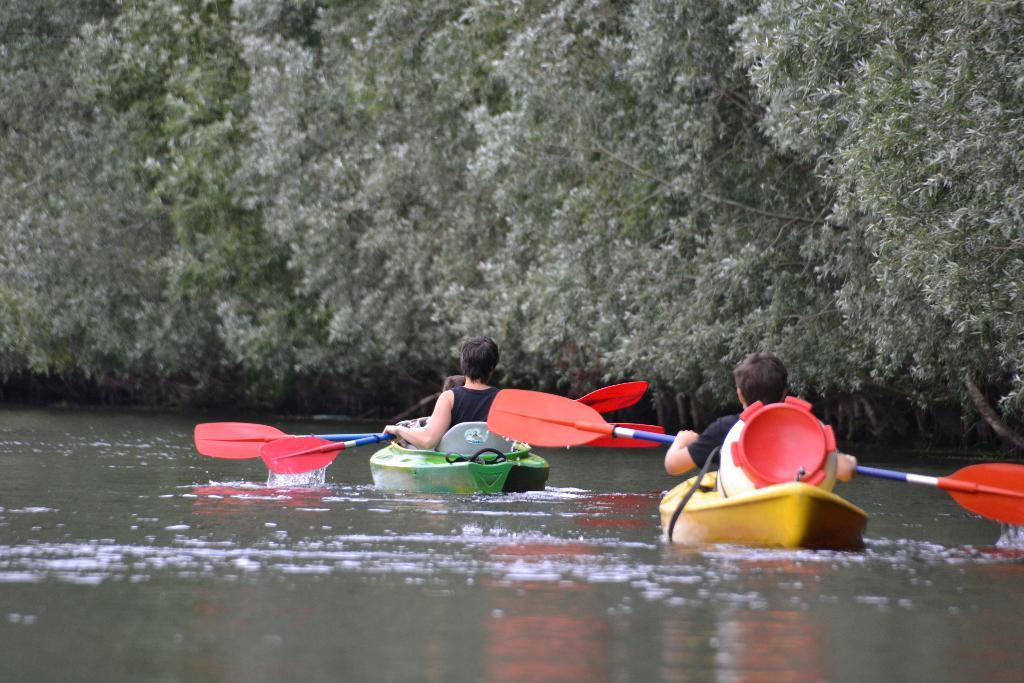What type of watercraft can be seen in the image? There are two inflatable boats in the image. Where are the boats located? The boats are sailing on a river. How many people are in the boats? There are three persons sitting in the boats. What can be seen in the background of the image? There are trees in the background of the image. What type of desk can be seen in the image? There is no desk present in the image; it features two inflatable boats sailing on a river with three persons in them. What is the stomach doing in the image? There is no mention of a stomach in the image; it focuses on inflatable boats, a river, and the people in the boats. 